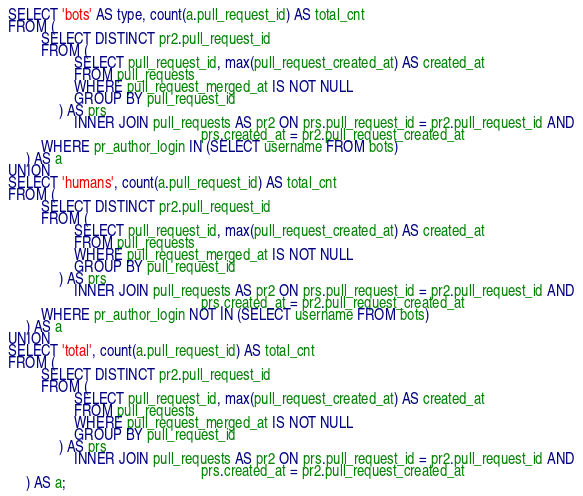Convert code to text. <code><loc_0><loc_0><loc_500><loc_500><_SQL_>SELECT 'bots' AS type, count(a.pull_request_id) AS total_cnt
FROM (
         SELECT DISTINCT pr2.pull_request_id
         FROM (
                  SELECT pull_request_id, max(pull_request_created_at) AS created_at
                  FROM pull_requests
                  WHERE pull_request_merged_at IS NOT NULL
                  GROUP BY pull_request_id
              ) AS prs
                  INNER JOIN pull_requests AS pr2 ON prs.pull_request_id = pr2.pull_request_id AND
                                                     prs.created_at = pr2.pull_request_created_at
         WHERE pr_author_login IN (SELECT username FROM bots)
     ) AS a
UNION
SELECT 'humans', count(a.pull_request_id) AS total_cnt
FROM (
         SELECT DISTINCT pr2.pull_request_id
         FROM (
                  SELECT pull_request_id, max(pull_request_created_at) AS created_at
                  FROM pull_requests
                  WHERE pull_request_merged_at IS NOT NULL
                  GROUP BY pull_request_id
              ) AS prs
                  INNER JOIN pull_requests AS pr2 ON prs.pull_request_id = pr2.pull_request_id AND
                                                     prs.created_at = pr2.pull_request_created_at
         WHERE pr_author_login NOT IN (SELECT username FROM bots)
     ) AS a
UNION
SELECT 'total', count(a.pull_request_id) AS total_cnt
FROM (
         SELECT DISTINCT pr2.pull_request_id
         FROM (
                  SELECT pull_request_id, max(pull_request_created_at) AS created_at
                  FROM pull_requests
                  WHERE pull_request_merged_at IS NOT NULL
                  GROUP BY pull_request_id
              ) AS prs
                  INNER JOIN pull_requests AS pr2 ON prs.pull_request_id = pr2.pull_request_id AND
                                                     prs.created_at = pr2.pull_request_created_at
     ) AS a;</code> 